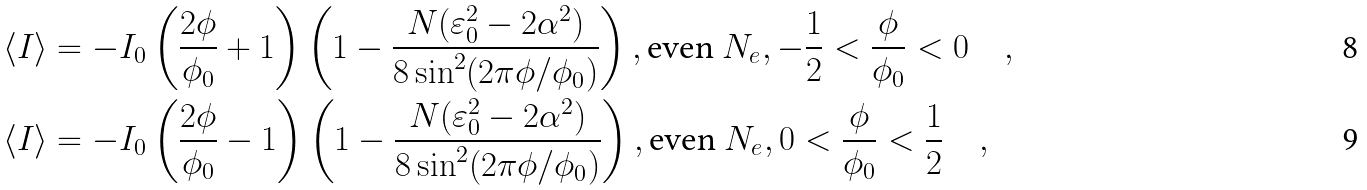Convert formula to latex. <formula><loc_0><loc_0><loc_500><loc_500>\langle I \rangle & = - I _ { 0 } \left ( \frac { 2 \phi } { \phi _ { 0 } } + 1 \right ) \left ( 1 - \frac { N ( \varepsilon ^ { 2 } _ { 0 } - 2 \alpha ^ { 2 } ) } { 8 \sin ^ { 2 } ( 2 \pi \phi / \phi _ { 0 } ) } \right ) , \text {even } N _ { e } , - \frac { 1 } { 2 } < \frac { \phi } { \phi _ { 0 } } < 0 \quad , \\ \langle I \rangle & = - I _ { 0 } \left ( \frac { 2 \phi } { \phi _ { 0 } } - 1 \right ) \left ( 1 - \frac { N ( \varepsilon ^ { 2 } _ { 0 } - 2 \alpha ^ { 2 } ) } { 8 \sin ^ { 2 } ( 2 \pi \phi / \phi _ { 0 } ) } \right ) , \text {even } N _ { e } , 0 < \frac { \phi } { \phi _ { 0 } } < \frac { 1 } { 2 } \quad ,</formula> 